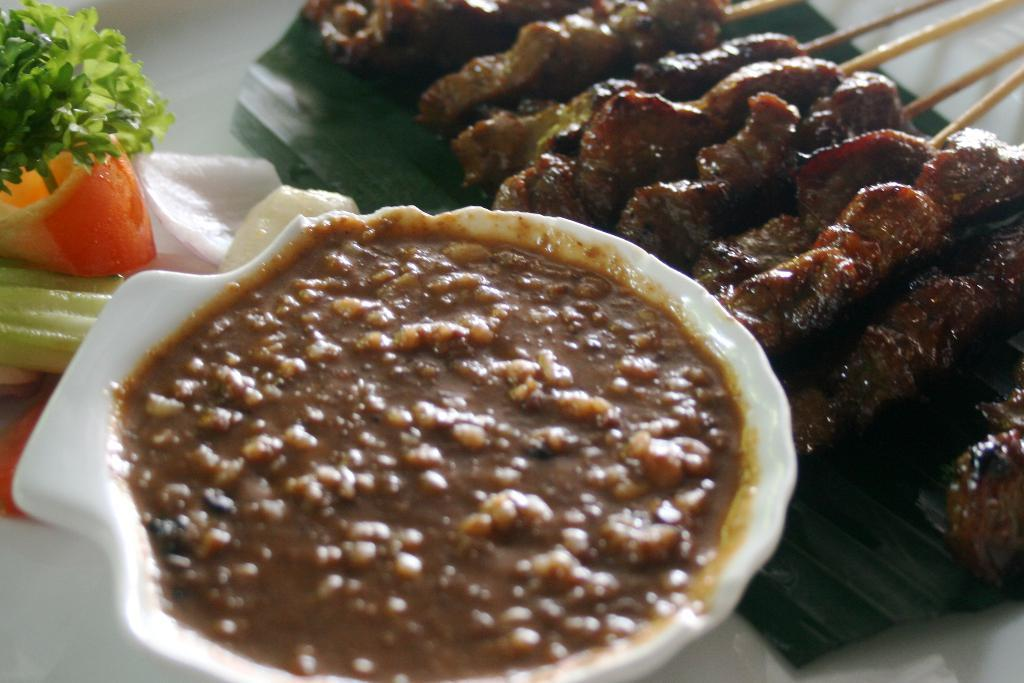What piece of furniture is present in the image? There is a table in the image. What type of food can be seen on the left side of the table? There is a salad on the left side of the table. What is contained in the cup in the image? There is a cup with some sauce in the image. What type of dish is present on the right side of the table? There are Seekh Kebabs on the right side of the table. What type of doctor is present in the image? There is no doctor present in the image. What type of fang can be seen in the image? There are no fangs present in the image. 